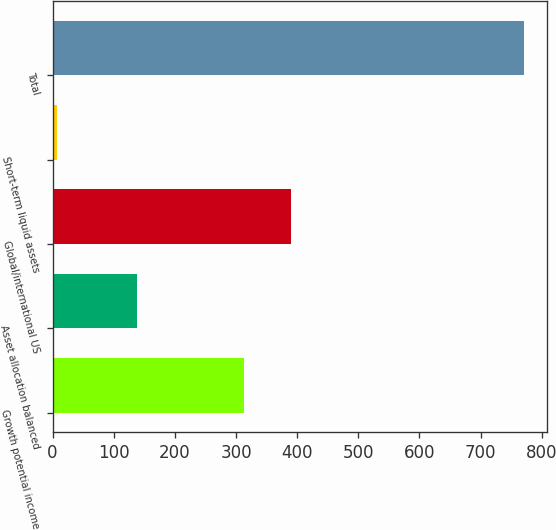<chart> <loc_0><loc_0><loc_500><loc_500><bar_chart><fcel>Growth potential income<fcel>Asset allocation balanced<fcel>Global/international US<fcel>Short-term liquid assets<fcel>Total<nl><fcel>312.9<fcel>138.3<fcel>389.31<fcel>6.8<fcel>770.9<nl></chart> 